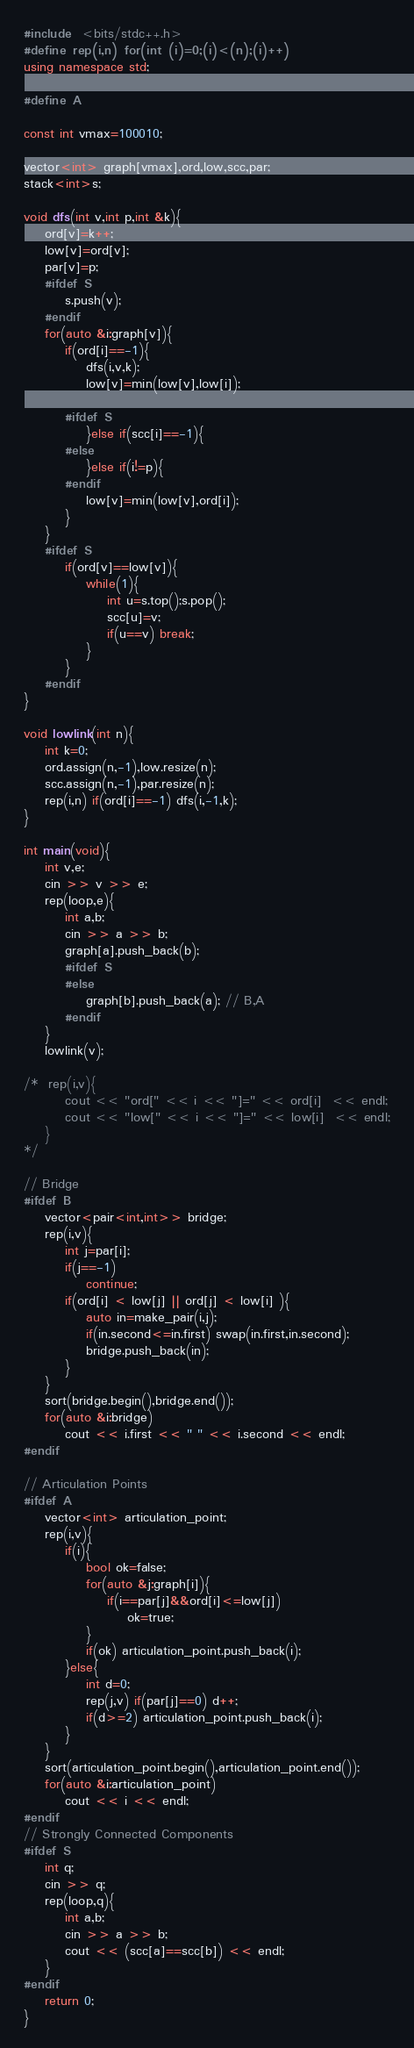<code> <loc_0><loc_0><loc_500><loc_500><_C++_>#include  <bits/stdc++.h>
#define rep(i,n) for(int (i)=0;(i)<(n);(i)++)
using namespace std;

#define A

const int vmax=100010;

vector<int> graph[vmax],ord,low,scc,par;
stack<int>s;

void dfs(int v,int p,int &k){
	ord[v]=k++;
	low[v]=ord[v];
	par[v]=p;
	#ifdef S
		s.push(v);
	#endif
	for(auto &i:graph[v]){
		if(ord[i]==-1){
			dfs(i,v,k);
			low[v]=min(low[v],low[i]);

		#ifdef S
			}else if(scc[i]==-1){
		#else
			}else if(i!=p){
		#endif
			low[v]=min(low[v],ord[i]);
		}
	}
	#ifdef S
		if(ord[v]==low[v]){
			while(1){
				int u=s.top();s.pop();
				scc[u]=v;
				if(u==v) break;
			}
		}
	#endif
}

void lowlink(int n){
	int k=0;
	ord.assign(n,-1),low.resize(n);
	scc.assign(n,-1),par.resize(n);
	rep(i,n) if(ord[i]==-1) dfs(i,-1,k);
}

int main(void){
	int v,e;
	cin >> v >> e;
	rep(loop,e){
		int a,b;
		cin >> a >> b;
		graph[a].push_back(b);
		#ifdef S
		#else
			graph[b].push_back(a); // B,A
		#endif
	}
	lowlink(v);

/*	rep(i,v){
		cout << "ord[" << i << "]=" << ord[i]  << endl;
		cout << "low[" << i << "]=" << low[i]  << endl;
	}
*/

// Bridge
#ifdef B
	vector<pair<int,int>> bridge;
	rep(i,v){
		int j=par[i];
		if(j==-1)
			continue;
		if(ord[i] < low[j] || ord[j] < low[i] ){
			auto in=make_pair(i,j);
			if(in.second<=in.first) swap(in.first,in.second);
			bridge.push_back(in);
		}
	}
	sort(bridge.begin(),bridge.end());
	for(auto &i:bridge)
		cout << i.first << " " << i.second << endl;
#endif

// Articulation Points
#ifdef A
	vector<int> articulation_point;
	rep(i,v){
		if(i){
			bool ok=false;
			for(auto &j:graph[i]){
				if(i==par[j]&&ord[i]<=low[j])
					ok=true;
			}
			if(ok) articulation_point.push_back(i);
		}else{
			int d=0;
			rep(j,v) if(par[j]==0) d++;
			if(d>=2) articulation_point.push_back(i);
		}
	}
	sort(articulation_point.begin(),articulation_point.end());
	for(auto &i:articulation_point)
		cout << i << endl;
#endif
// Strongly Connected Components
#ifdef S
	int q;
	cin >> q;
	rep(loop,q){
		int a,b;
		cin >> a >> b;
		cout << (scc[a]==scc[b]) << endl;
	}
#endif
	return 0;
}</code> 